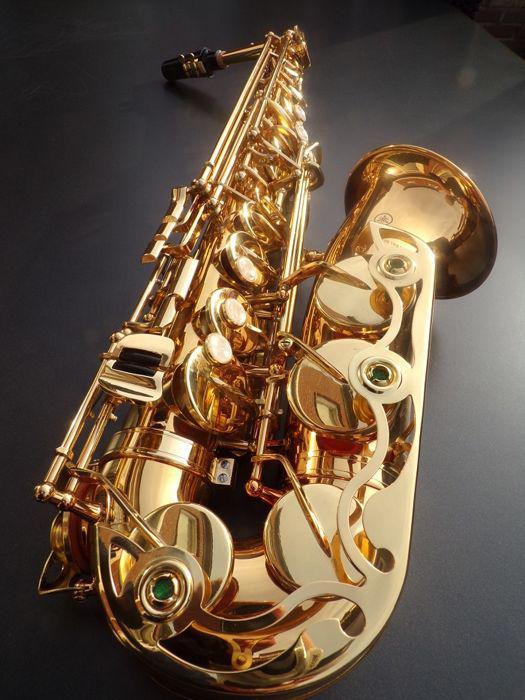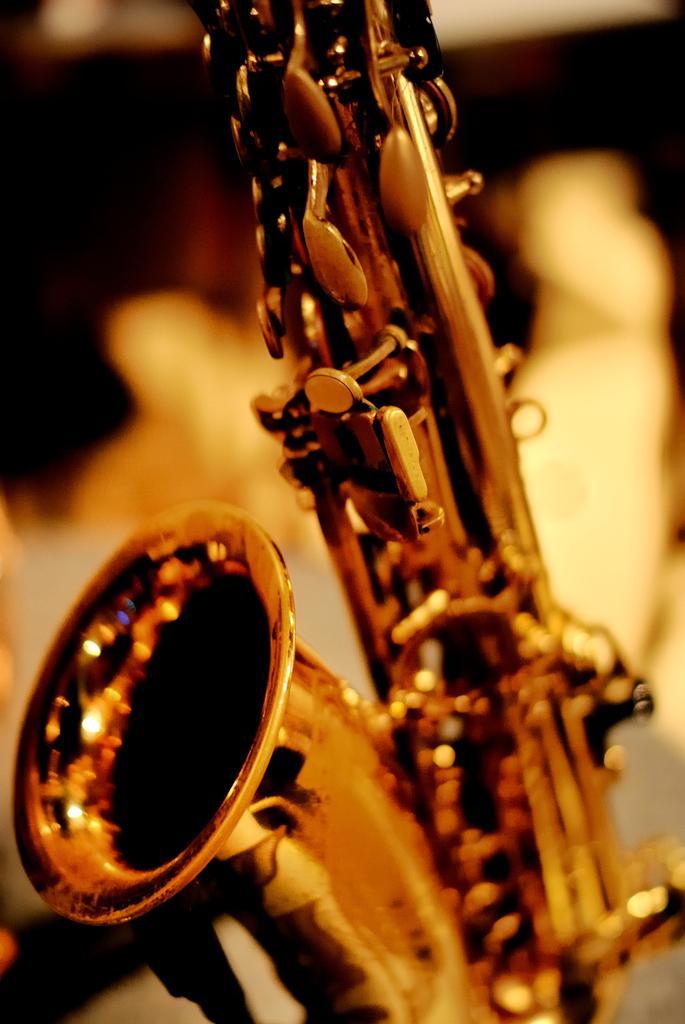The first image is the image on the left, the second image is the image on the right. For the images displayed, is the sentence "At least two saxophones face left." factually correct? Answer yes or no. No. 